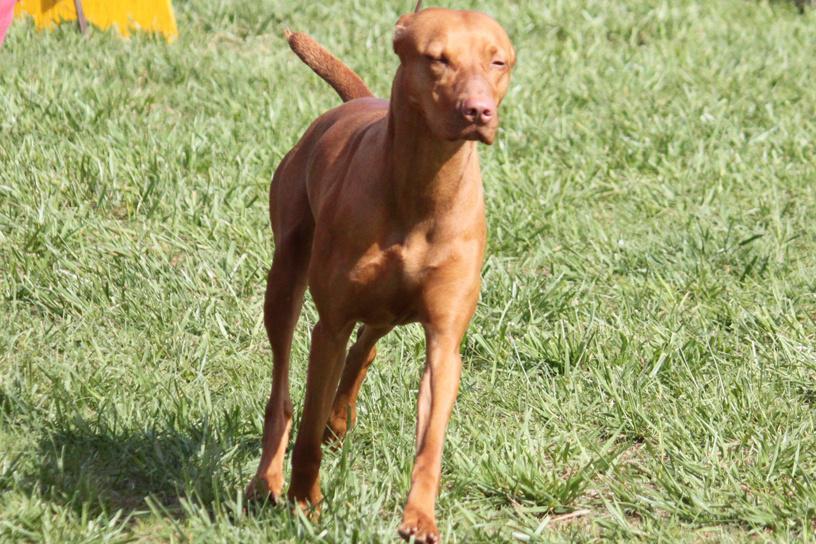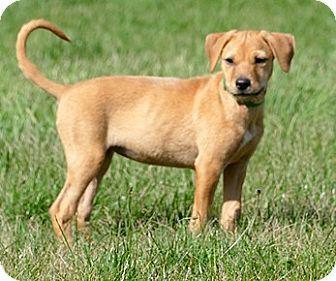The first image is the image on the left, the second image is the image on the right. Given the left and right images, does the statement "One image shows a dark red-orange dog standing and wearing a lime green collar, and the other image features a more tan dog with something around its neck." hold true? Answer yes or no. No. 